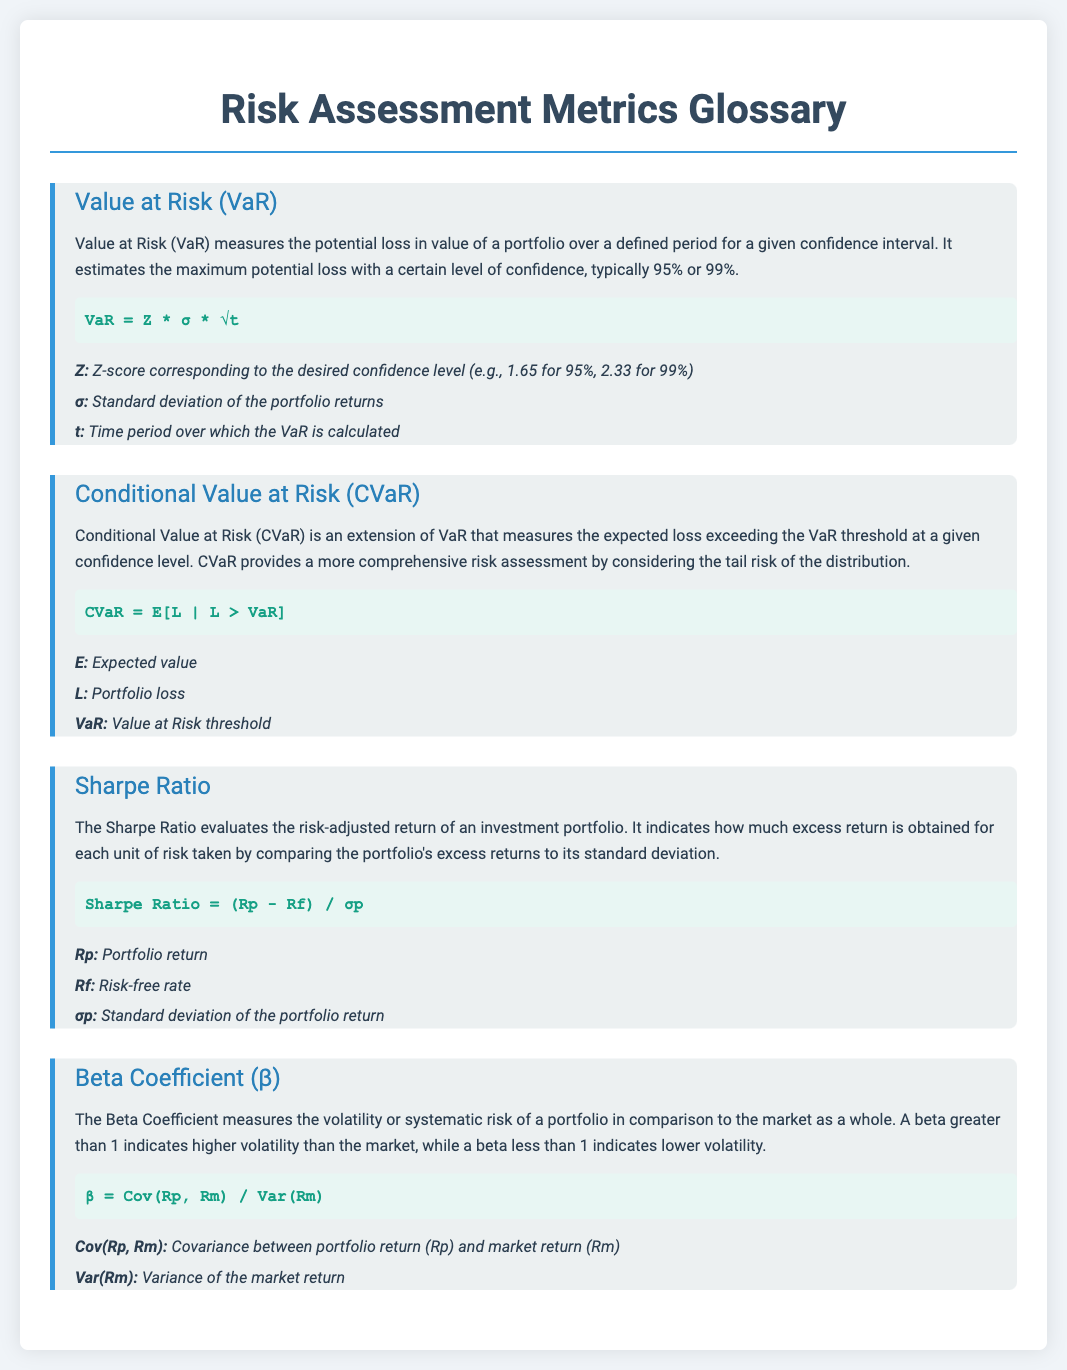What does VaR stand for? VaR is the acronym for Value at Risk, which measures potential loss in value of a portfolio.
Answer: Value at Risk What is the confidence interval commonly used for VaR? The document states that VaR typically uses a confidence interval of 95% or 99%.
Answer: 95% or 99% What does CVaR measure? CVaR measures the expected loss exceeding the VaR threshold at a given confidence level.
Answer: Expected loss What is the formula for the Sharpe Ratio? The formula for the Sharpe Ratio is given in the document.
Answer: (Rp - Rf) / σp What do a Beta Coefficient greater than 1 indicate? A beta greater than 1 indicates higher volatility than the market.
Answer: Higher volatility What is represented by σ in the VaR formula? The document defines σ as the standard deviation of the portfolio returns.
Answer: Standard deviation How does the Sharpe Ratio evaluate return? The Sharpe Ratio evaluates risk-adjusted return by comparing excess returns to standard deviation.
Answer: Risk-adjusted return What is the expected value represented by in the CVaR formula? The document indicates that E represents expected value in the CVaR formula.
Answer: Expected value What does a Beta Coefficient less than 1 indicate? A beta less than 1 indicates lower volatility than the market, as specified in the document.
Answer: Lower volatility 